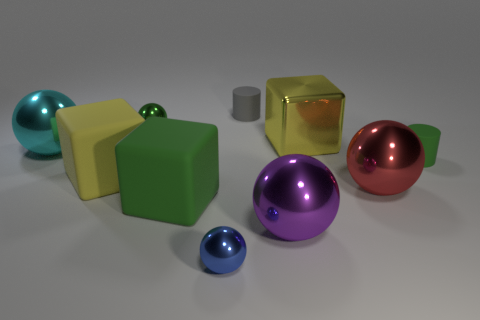Subtract all tiny spheres. How many spheres are left? 3 Subtract all red balls. How many balls are left? 4 Subtract 1 cubes. How many cubes are left? 2 Subtract all green balls. Subtract all gray cylinders. How many balls are left? 4 Subtract all blocks. How many objects are left? 7 Add 2 large red balls. How many large red balls are left? 3 Add 6 large cyan metallic cylinders. How many large cyan metallic cylinders exist? 6 Subtract 0 yellow spheres. How many objects are left? 10 Subtract all gray things. Subtract all big green cubes. How many objects are left? 8 